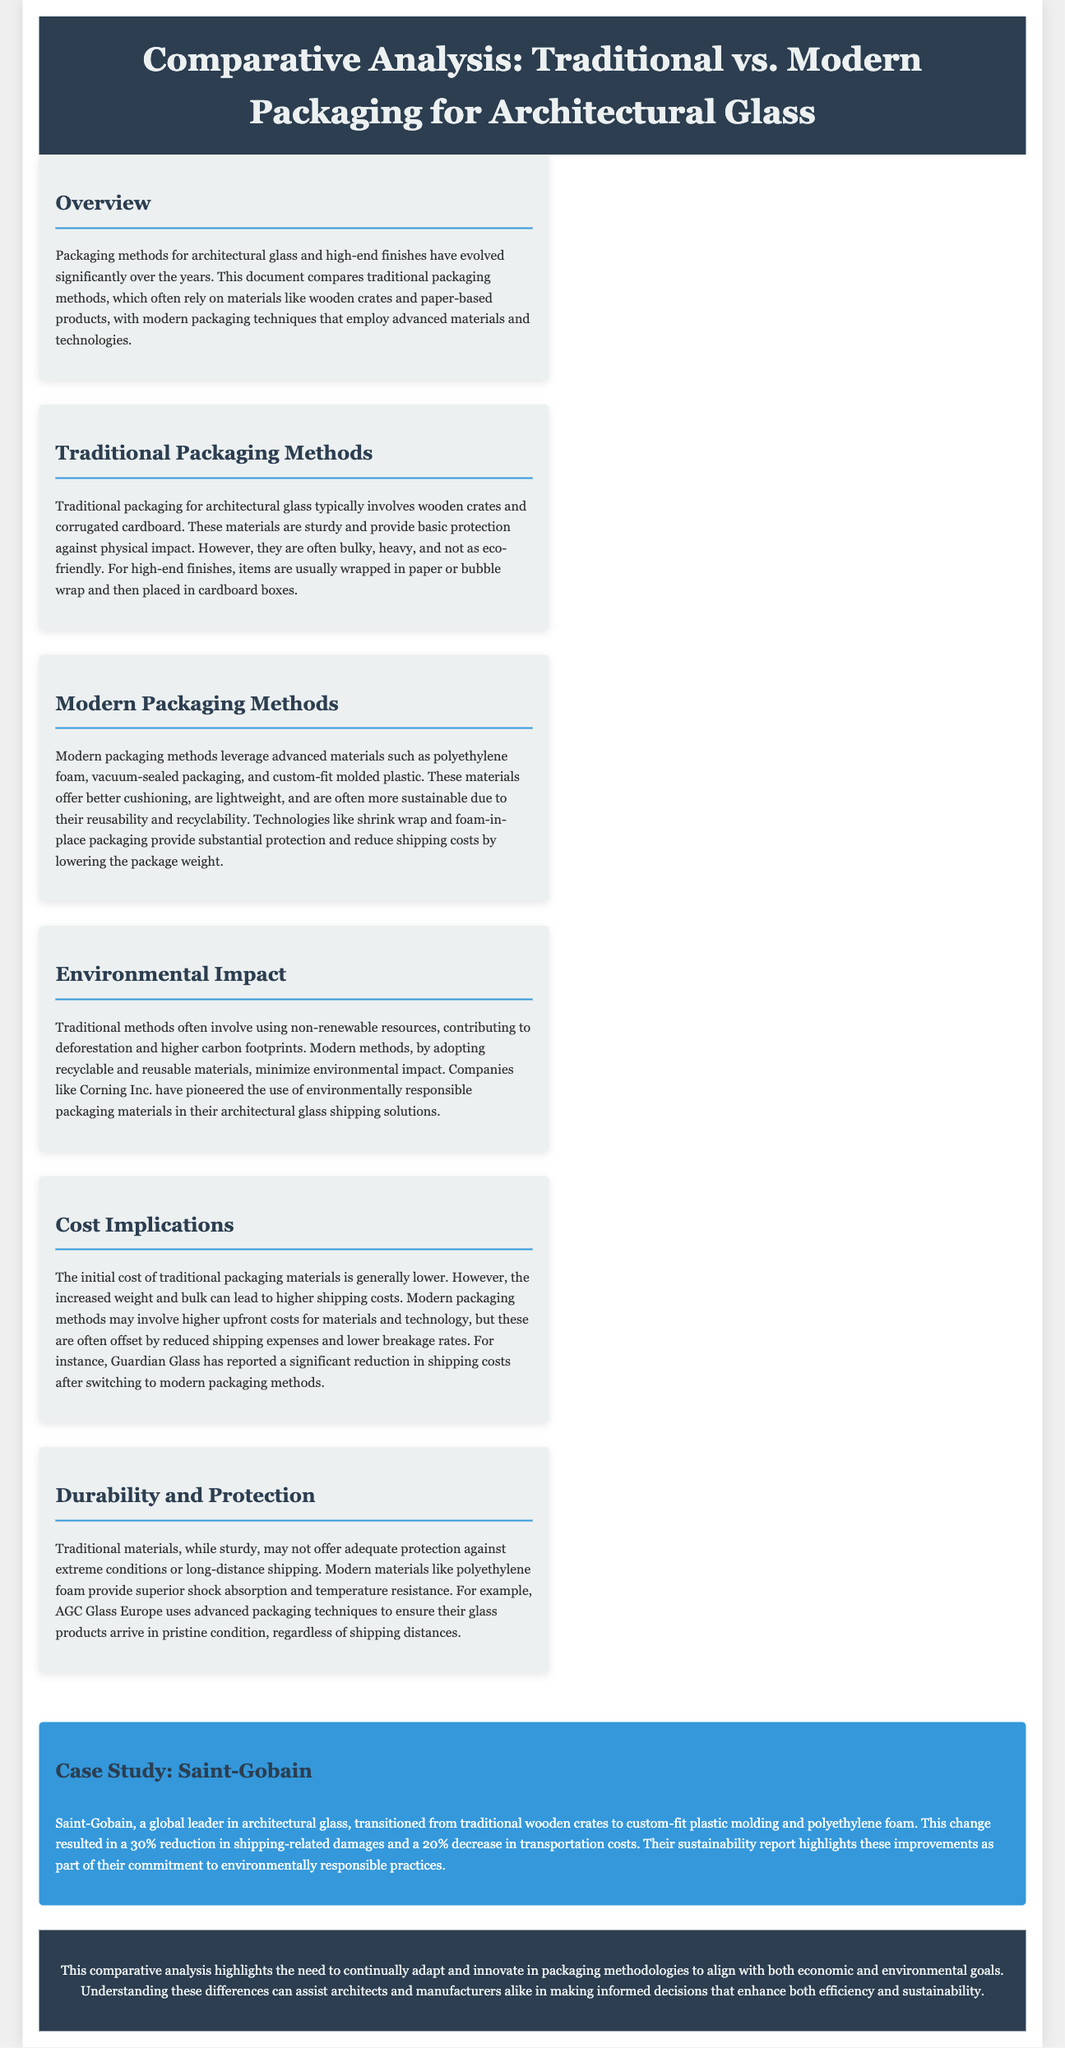What are the key materials used in traditional packaging? The traditional packaging typically involves wooden crates and corrugated cardboard.
Answer: Wooden crates and corrugated cardboard What is a benefit of modern packaging techniques? Modern packaging techniques leverage advanced materials that offer better cushioning and are often more sustainable.
Answer: Better cushioning, sustainability What percentage reduction in shipping-related damages did Saint-Gobain achieve? Saint-Gobain reported a 30% reduction in shipping-related damages after changing their packaging methods.
Answer: 30% Which company has pioneered environmentally responsible packaging materials? Companies like Corning Inc. have pioneered the use of environmentally responsible packaging materials in their architectural glass shipping solutions.
Answer: Corning Inc What is a key disadvantage of traditional packaging? Traditional methods are often bulky, heavy, and not as eco-friendly.
Answer: Bulky, heavy, not eco-friendly What type of material does AGC Glass Europe use for better product protection? AGC Glass Europe uses advanced packaging techniques to ensure glass products arrive in pristine condition.
Answer: Advanced packaging techniques What was the cost impact of traditional packaging methods compared to modern methods? The initial cost of traditional packaging materials is generally lower, but modern methods may offset higher upfront costs with reduced shipping expenses.
Answer: Higher upfront costs, reduced shipping expenses What are modern packaging methods designed to reduce during transportation? Modern packaging methods are designed to reduce shipping costs by lowering the package weight.
Answer: Shipping costs, package weight What environmental impact do traditional packaging methods have? Traditional methods often involve using non-renewable resources, contributing to deforestation and higher carbon footprints.
Answer: Deforestation, higher carbon footprints What is the main focus of this document? The main focus of this document is a comparative analysis of traditional vs. modern packaging for architectural glass and high-end finishes.
Answer: Comparative analysis 